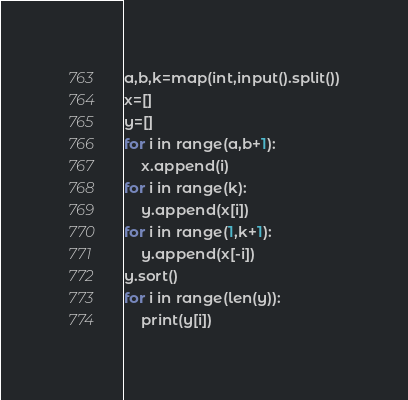<code> <loc_0><loc_0><loc_500><loc_500><_Python_>a,b,k=map(int,input().split())
x=[]
y=[]
for i in range(a,b+1):
    x.append(i)
for i in range(k):
    y.append(x[i])
for i in range(1,k+1):
    y.append(x[-i])
y.sort()
for i in range(len(y)):
    print(y[i])</code> 